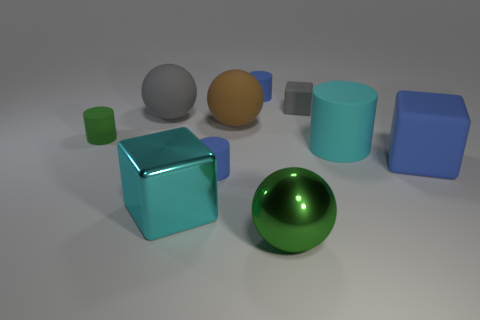Can you describe the relative sizes of the objects in the image? Certainly! In the image, we have a variety of geometric shapes of different sizes. Starting from the left, we see a small green cube and a smaller green cylinder. There's a substantial cyan blue cube in front, and behind it, a large blue glossy cube. Next to these, there is a medium-sized matte grey sphere, a smaller yellow sphere, and a blue cylinder of medium height. On the right, we observe a large brown cuboid that is taller than any other object in the scene. 